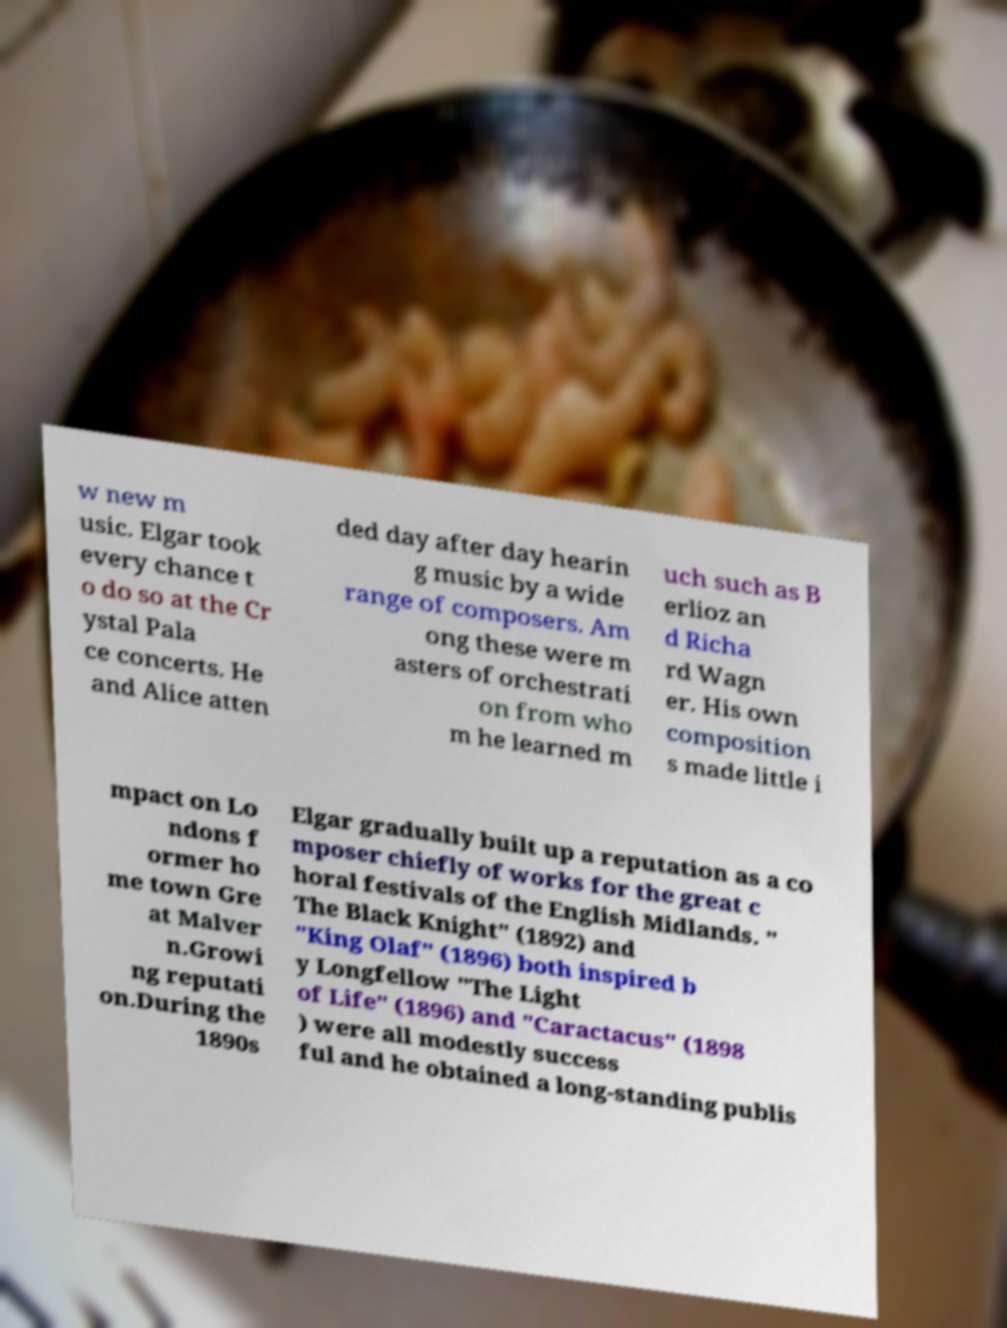Can you accurately transcribe the text from the provided image for me? w new m usic. Elgar took every chance t o do so at the Cr ystal Pala ce concerts. He and Alice atten ded day after day hearin g music by a wide range of composers. Am ong these were m asters of orchestrati on from who m he learned m uch such as B erlioz an d Richa rd Wagn er. His own composition s made little i mpact on Lo ndons f ormer ho me town Gre at Malver n.Growi ng reputati on.During the 1890s Elgar gradually built up a reputation as a co mposer chiefly of works for the great c horal festivals of the English Midlands. " The Black Knight" (1892) and "King Olaf" (1896) both inspired b y Longfellow "The Light of Life" (1896) and "Caractacus" (1898 ) were all modestly success ful and he obtained a long-standing publis 